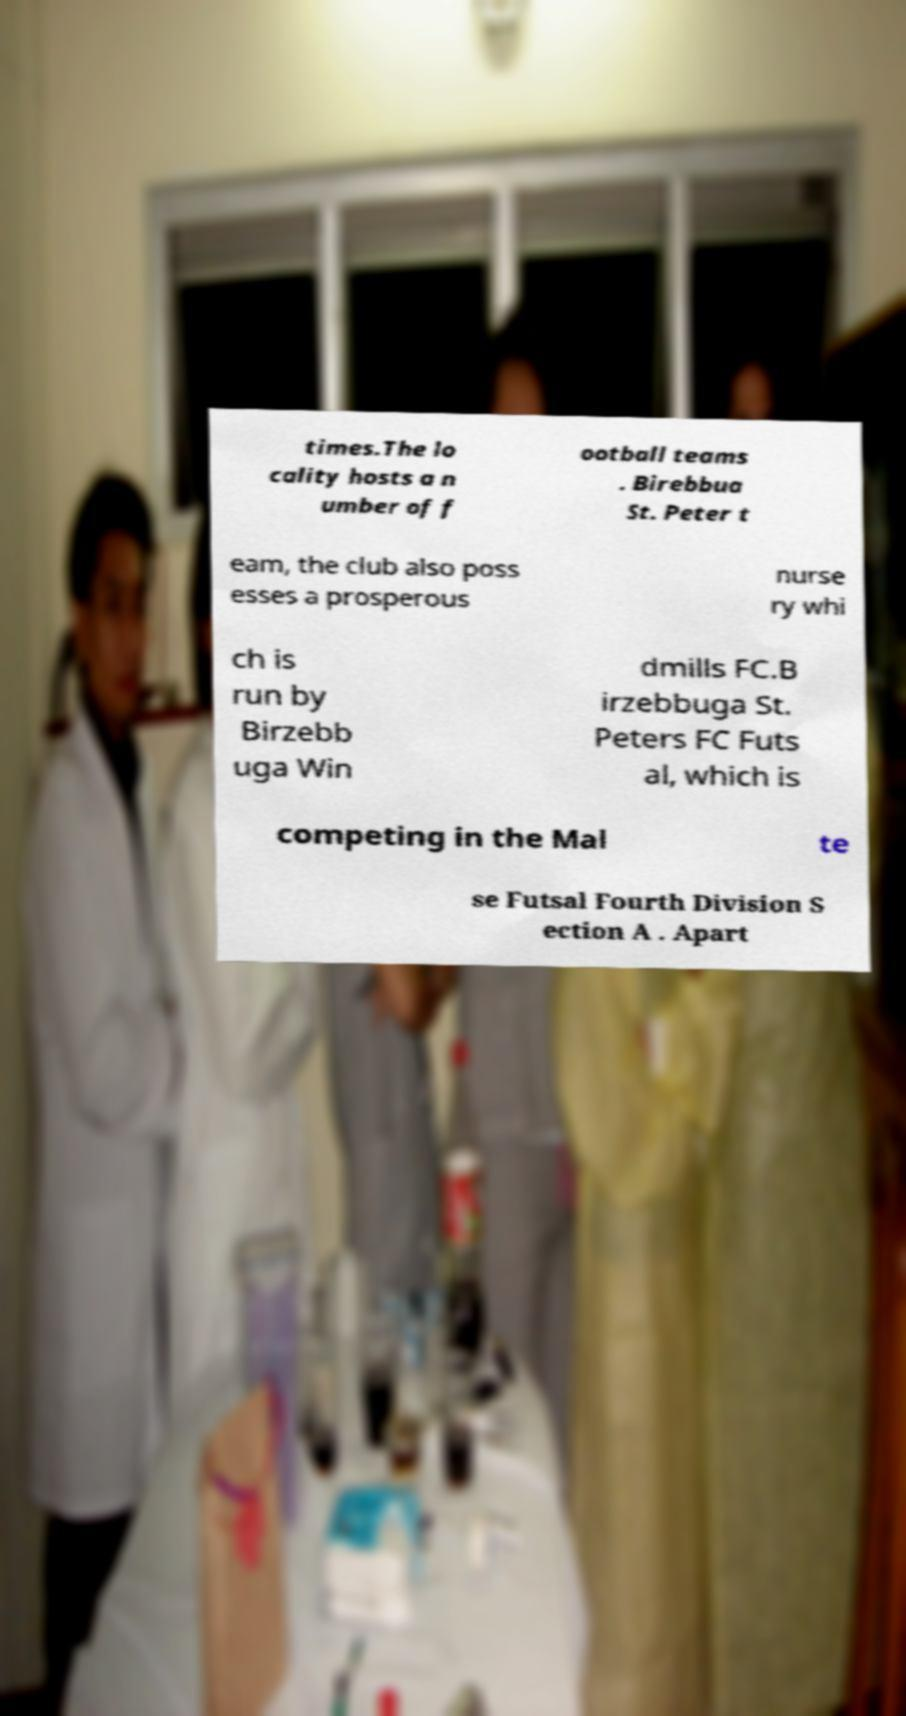I need the written content from this picture converted into text. Can you do that? times.The lo cality hosts a n umber of f ootball teams . Birebbua St. Peter t eam, the club also poss esses a prosperous nurse ry whi ch is run by Birzebb uga Win dmills FC.B irzebbuga St. Peters FC Futs al, which is competing in the Mal te se Futsal Fourth Division S ection A . Apart 